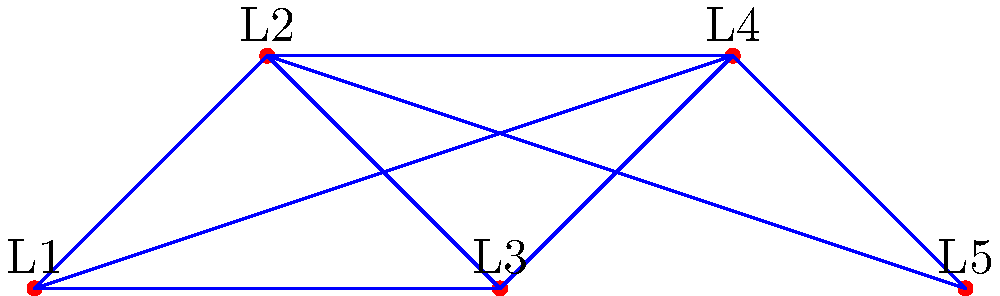Your grandfather, an Emory alumnus, shares a map of the university's major landmarks. The map shows 5 landmarks (L1 to L5) connected by paths. How many different routes are there to visit all 5 landmarks exactly once, starting at L1 and ending at L5? Let's approach this step-by-step:

1) We need to start at L1 and end at L5, so we're looking for paths that go through L2, L3, and L4 in some order.

2) This is a permutation problem. We need to find how many ways we can arrange L2, L3, and L4.

3) The number of permutations of 3 distinct objects is calculated by:

   $3! = 3 \times 2 \times 1 = 6$

4) However, not all of these permutations may be valid paths in our graph. We need to check each one:

   L1 - L2 - L3 - L4 - L5 (valid)
   L1 - L2 - L4 - L3 - L5 (valid)
   L1 - L3 - L2 - L4 - L5 (valid)
   L1 - L3 - L4 - L2 - L5 (valid)
   L1 - L4 - L2 - L3 - L5 (valid)
   L1 - L4 - L3 - L2 - L5 (valid)

5) We can see that all 6 permutations are valid paths in our graph.

Therefore, there are 6 different routes to visit all 5 landmarks exactly once, starting at L1 and ending at L5.
Answer: 6 routes 